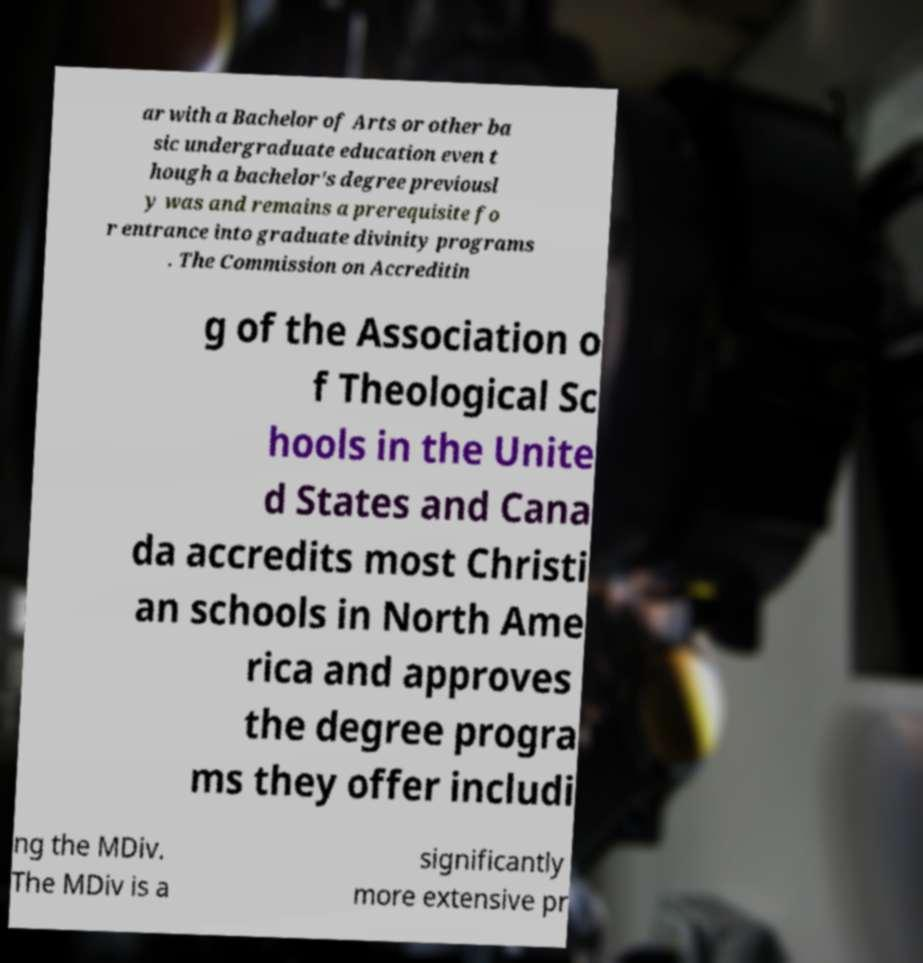I need the written content from this picture converted into text. Can you do that? ar with a Bachelor of Arts or other ba sic undergraduate education even t hough a bachelor's degree previousl y was and remains a prerequisite fo r entrance into graduate divinity programs . The Commission on Accreditin g of the Association o f Theological Sc hools in the Unite d States and Cana da accredits most Christi an schools in North Ame rica and approves the degree progra ms they offer includi ng the MDiv. The MDiv is a significantly more extensive pr 